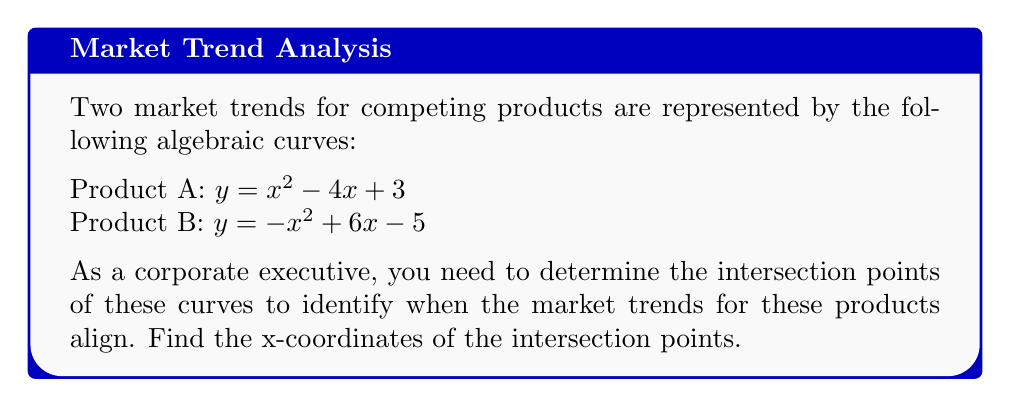What is the answer to this math problem? To find the intersection points, we need to solve the equation where both curves are equal:

1) Set the equations equal to each other:
   $x^2 - 4x + 3 = -x^2 + 6x - 5$

2) Rearrange the equation to standard form:
   $x^2 - 4x + 3 + x^2 - 6x + 5 = 0$
   $2x^2 - 10x + 8 = 0$

3) Divide everything by 2 to simplify:
   $x^2 - 5x + 4 = 0$

4) This is a quadratic equation. We can solve it using the quadratic formula:
   $x = \frac{-b \pm \sqrt{b^2 - 4ac}}{2a}$

   Where $a = 1$, $b = -5$, and $c = 4$

5) Plugging these values into the quadratic formula:
   $x = \frac{5 \pm \sqrt{25 - 16}}{2} = \frac{5 \pm 3}{2}$

6) Solving:
   $x_1 = \frac{5 + 3}{2} = 4$
   $x_2 = \frac{5 - 3}{2} = 1$

Therefore, the x-coordinates of the intersection points are 1 and 4.
Answer: $x = 1$ and $x = 4$ 